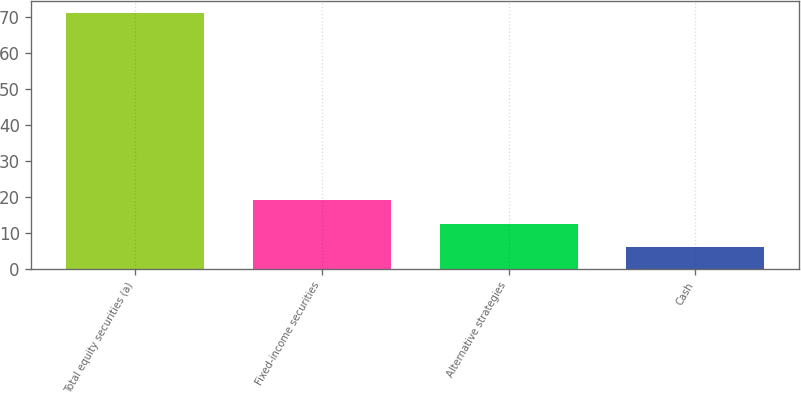<chart> <loc_0><loc_0><loc_500><loc_500><bar_chart><fcel>Total equity securities (a)<fcel>Fixed-income securities<fcel>Alternative strategies<fcel>Cash<nl><fcel>71<fcel>19<fcel>12.5<fcel>6<nl></chart> 